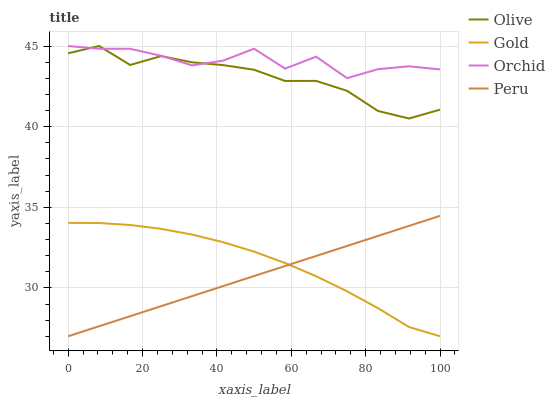Does Gold have the minimum area under the curve?
Answer yes or no. No. Does Gold have the maximum area under the curve?
Answer yes or no. No. Is Gold the smoothest?
Answer yes or no. No. Is Gold the roughest?
Answer yes or no. No. Does Orchid have the lowest value?
Answer yes or no. No. Does Peru have the highest value?
Answer yes or no. No. Is Peru less than Olive?
Answer yes or no. Yes. Is Olive greater than Peru?
Answer yes or no. Yes. Does Peru intersect Olive?
Answer yes or no. No. 